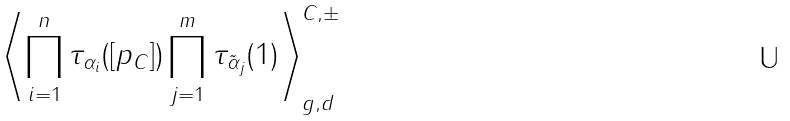Convert formula to latex. <formula><loc_0><loc_0><loc_500><loc_500>\left \langle \prod _ { i = 1 } ^ { n } \tau _ { \alpha _ { i } } ( [ p _ { C } ] ) \prod _ { j = 1 } ^ { m } \tau _ { \tilde { \alpha } _ { j } } ( 1 ) \right \rangle _ { g , d } ^ { C , \pm }</formula> 